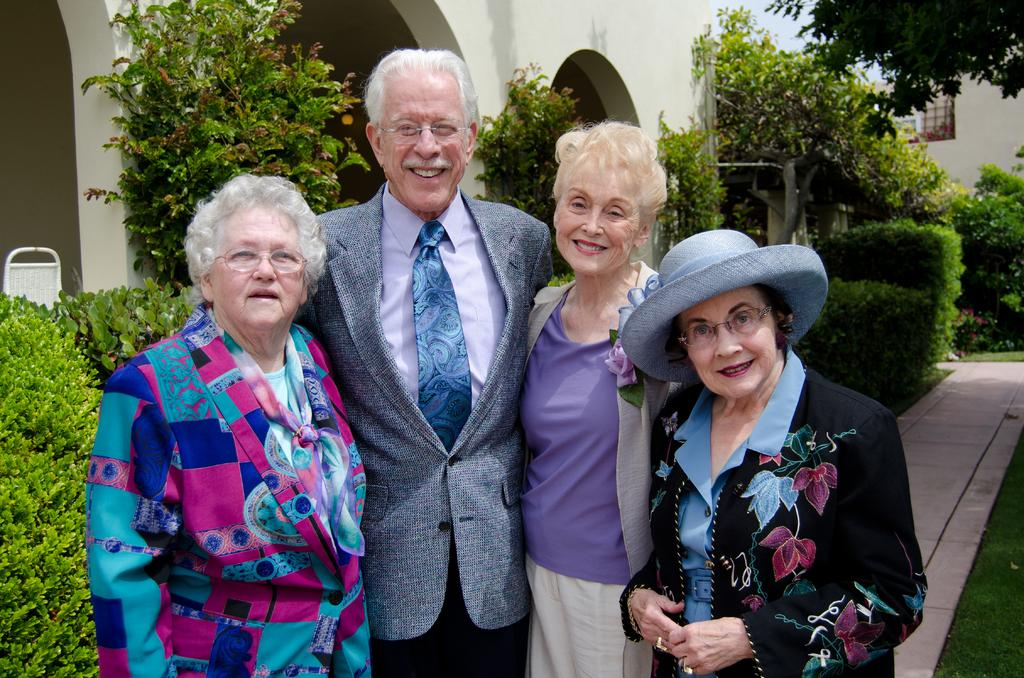How many people are in the image? There are four persons in the image. What type of vegetation can be seen in the image? There are plants and grass visible in the image. What is the background element in the image? There is a wall in the image. What type of prose is being recited by the birds in the image? There are no birds present in the image, so there is no prose being recited. 